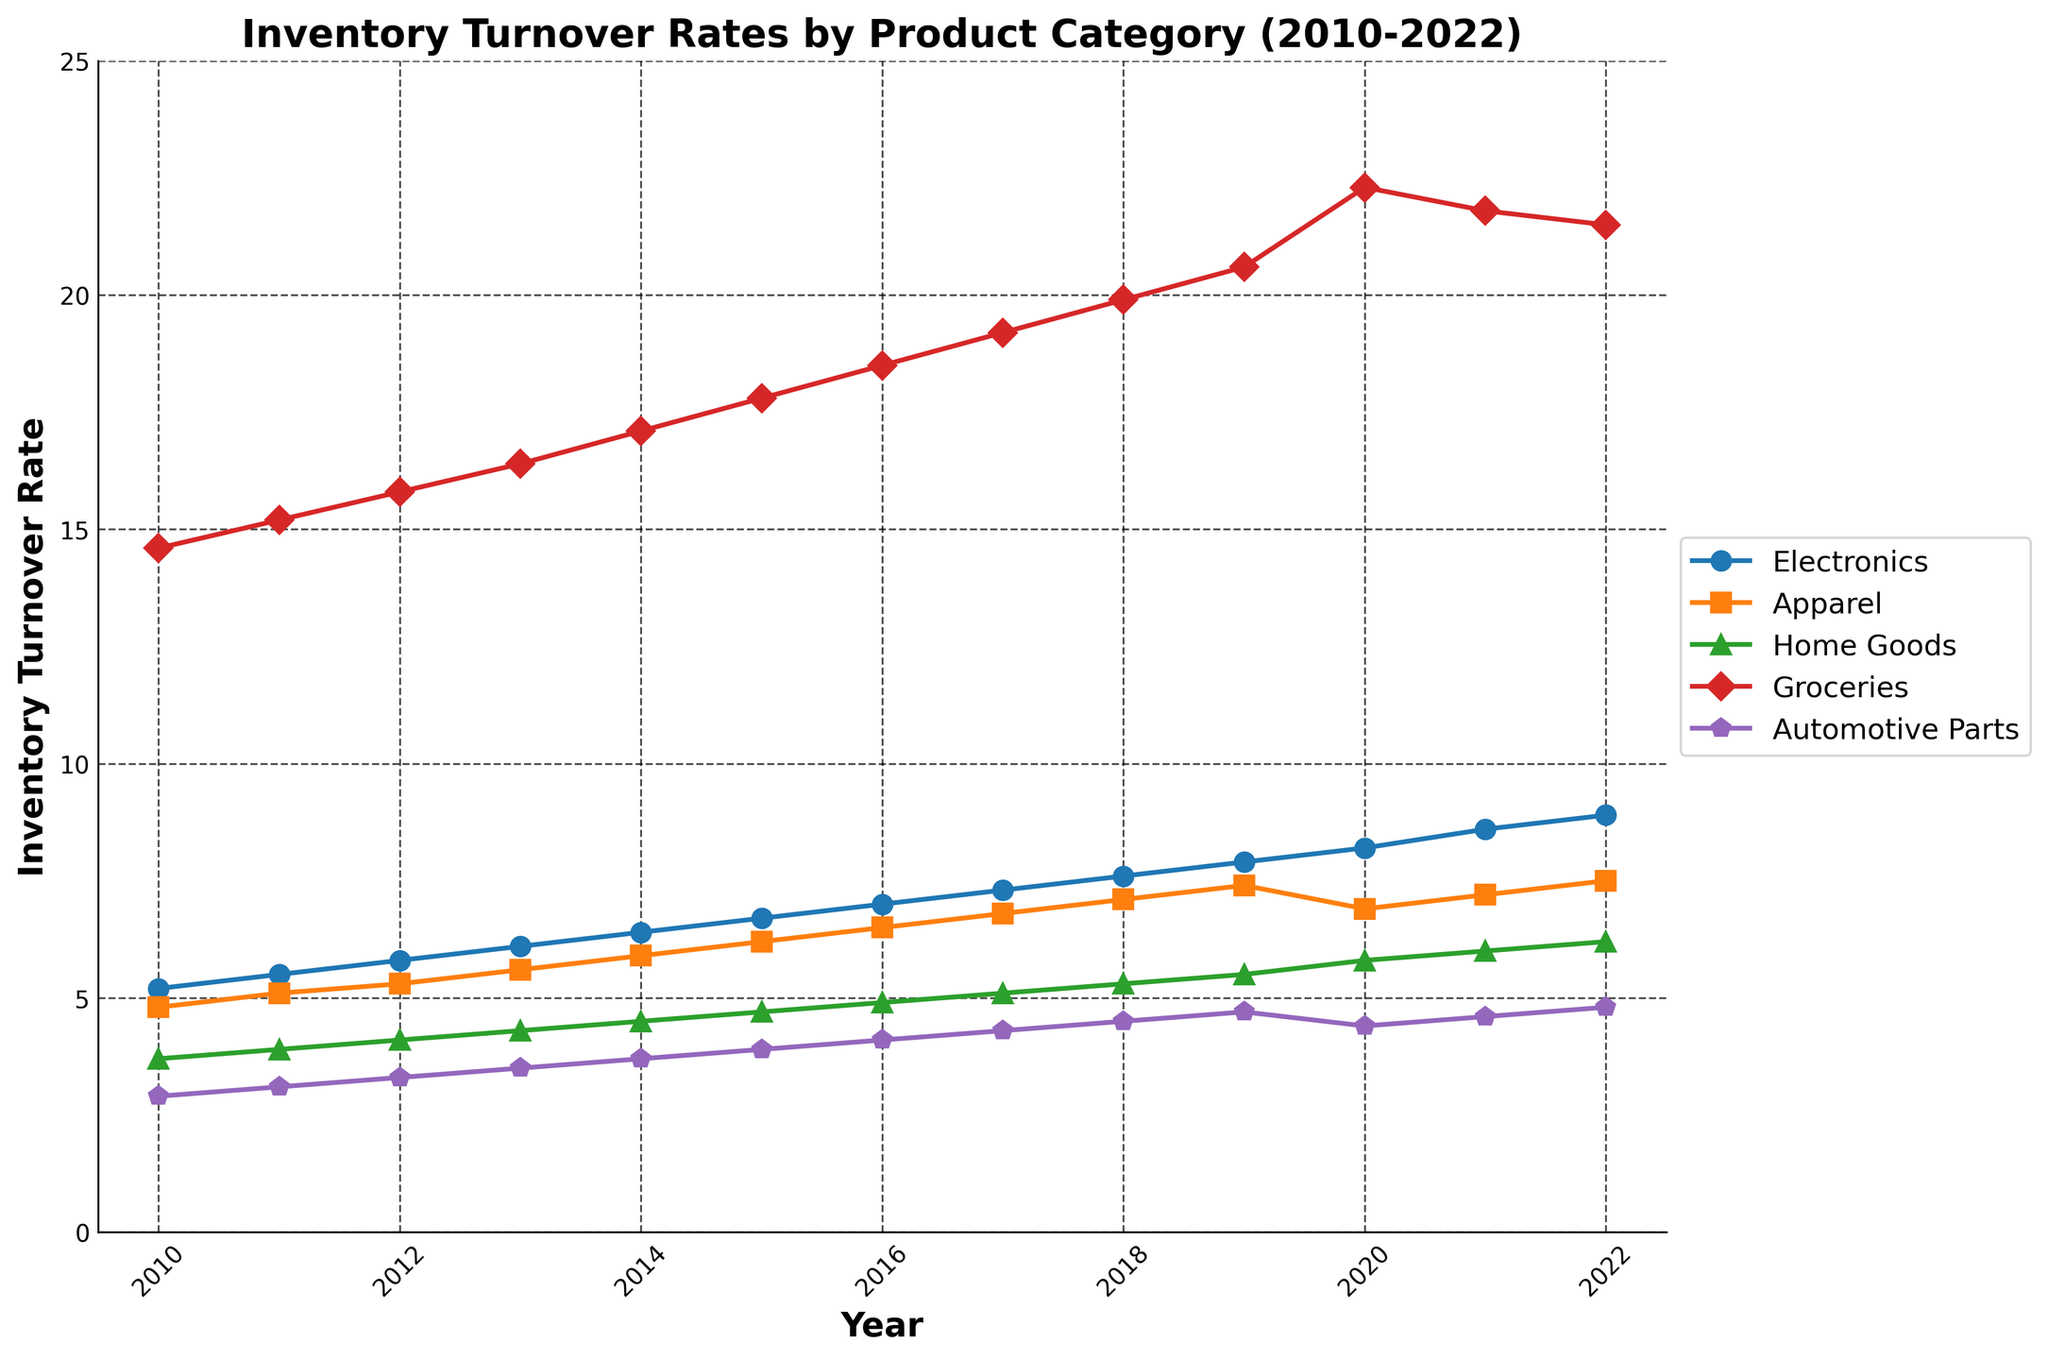What is the inventory turnover rate for Electronics in 2022? Look at the line labeled "Electronics" in 2022. The value corresponds to the y-axis.
Answer: 8.9 How did the inventory turnover rate for Apparel change from 2010 to 2022? Compare the value of Apparel in 2010 to the value in 2022. In 2010, it's 4.8, and in 2022, it's 7.5. Calculate the difference: 7.5 - 4.8.
Answer: Increased by 2.7 Which product category had the highest turnover rate in 2021? Look at the y-values for all categories in 2021. Groceries has the highest value among all, which is 21.8.
Answer: Groceries Between which two consecutive years did Automative Parts see the smallest increase in turnover rate? Look at the turnover rates for Automative Parts from year to year and calculate the differences between consecutive years. The smallest increase is between 2019 (4.7) and 2020 (4.4). The difference is 4.4 - 4.7 = -0.3 (this is actually a decrease, but if we consider an increase, 2021 to 2022 where the increase is 4.8 - 4.6 = 0.2).
Answer: 2021 to 2022 What is the average inventory turnover rate for Home Goods from 2010 to 2022? Sum up the Home Goods turnover rates from 2010 to 2022 and divide by the number of years. \( (3.7 + 3.9 + 4.1 + 4.3 + 4.5 + 4.7 + 4.9 + 5.1 + 5.3 + 5.5 + 5.8 + 6.0 + 6.2)/13 \approx 4.8 \)
Answer: 4.8 How much higher was the turnover rate for Groceries compared to Automotive Parts in 2022? Subtract the turnover rate of Automotive Parts from Groceries in 2022. (21.5 - 4.8 = 16.7).
Answer: 16.7 In which year did Electronics surpass a turnover rate of 7 for the first time? Look along the "Electronics" line until it first exceeds 7, which occurs in 2016.
Answer: 2016 Which category had the most significant increase in turnover rate over the full period? Calculate the difference between the turnover rates in 2022 and 2010 for each category and compare these values. Groceries has the largest increase: 21.5 - 14.6 = 6.9.
Answer: Groceries Did any category see a decrease in turnover rate between 2020 and 2021? Check the values for all categories between 2020 and 2021. Groceries decreased from 22.3 to 21.8.
Answer: Groceries 